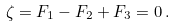<formula> <loc_0><loc_0><loc_500><loc_500>\zeta = F _ { 1 } - F _ { 2 } + F _ { 3 } = 0 \, .</formula> 